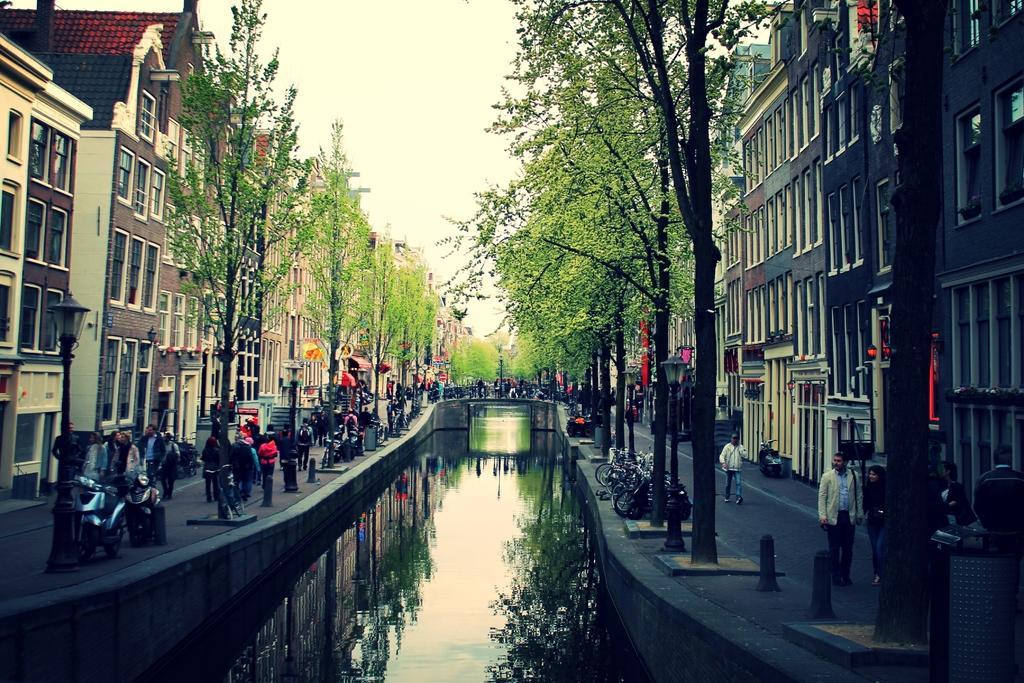How would you summarize this image in a sentence or two? In this image at the bottom there is a river and on the right side and left side there are some people who are walking on the road, and also there are some bikes and there are some buildings, trees. On the top of the image there is sky. 